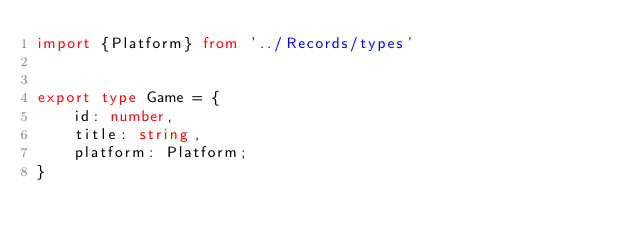<code> <loc_0><loc_0><loc_500><loc_500><_TypeScript_>import {Platform} from '../Records/types'


export type Game = {
    id: number,
    title: string,
    platform: Platform;
}</code> 